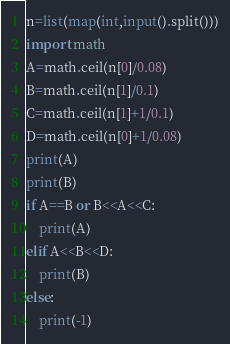<code> <loc_0><loc_0><loc_500><loc_500><_Python_>n=list(map(int,input().split()))
import math
A=math.ceil(n[0]/0.08)
B=math.ceil(n[1]/0.1)
C=math.ceil(n[1]+1/0.1)
D=math.ceil(n[0]+1/0.08)
print(A)
print(B)
if A==B or B<<A<<C:
    print(A)
elif A<<B<<D:
    print(B)
else:
    print(-1)

</code> 